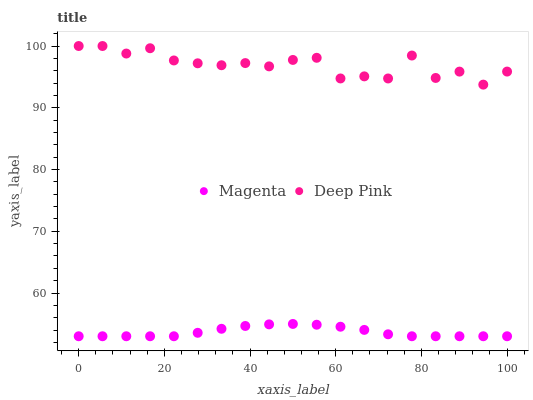Does Magenta have the minimum area under the curve?
Answer yes or no. Yes. Does Deep Pink have the maximum area under the curve?
Answer yes or no. Yes. Does Deep Pink have the minimum area under the curve?
Answer yes or no. No. Is Magenta the smoothest?
Answer yes or no. Yes. Is Deep Pink the roughest?
Answer yes or no. Yes. Is Deep Pink the smoothest?
Answer yes or no. No. Does Magenta have the lowest value?
Answer yes or no. Yes. Does Deep Pink have the lowest value?
Answer yes or no. No. Does Deep Pink have the highest value?
Answer yes or no. Yes. Is Magenta less than Deep Pink?
Answer yes or no. Yes. Is Deep Pink greater than Magenta?
Answer yes or no. Yes. Does Magenta intersect Deep Pink?
Answer yes or no. No. 